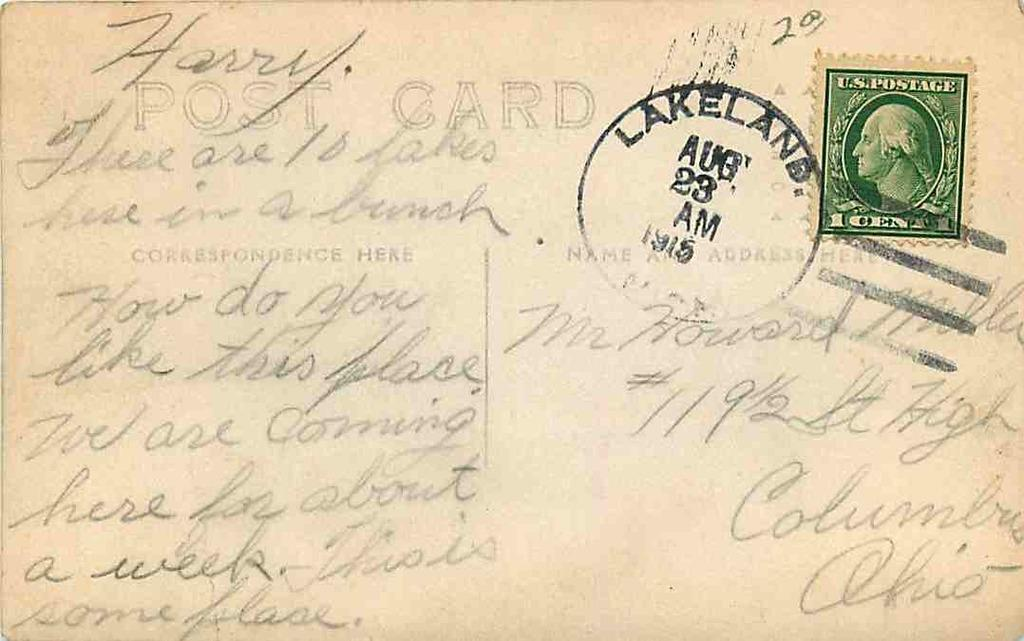<image>
Offer a succinct explanation of the picture presented. An old postcard has a postmark that has the month August on it. 